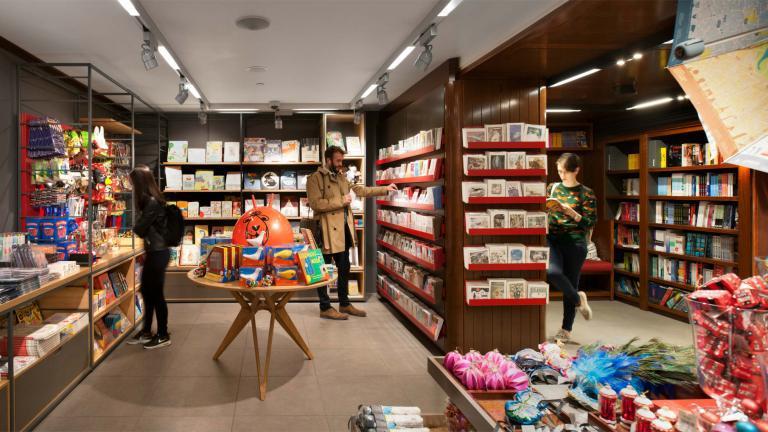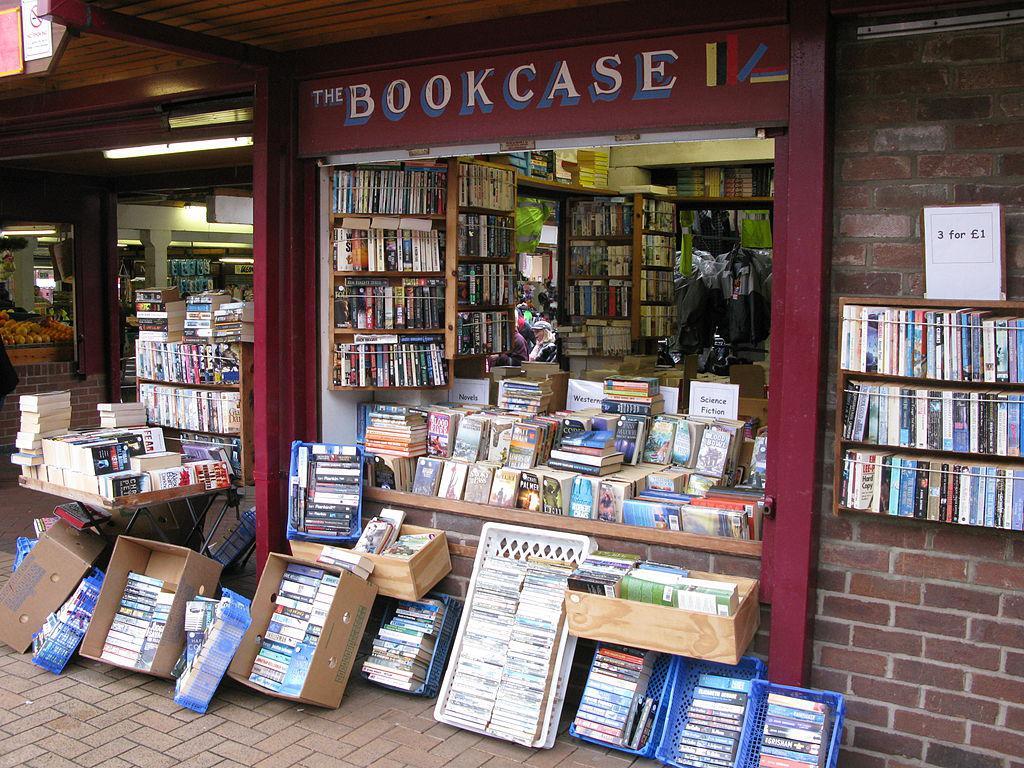The first image is the image on the left, the second image is the image on the right. Examine the images to the left and right. Is the description "There are at least two people in the image on the left." accurate? Answer yes or no. Yes. 